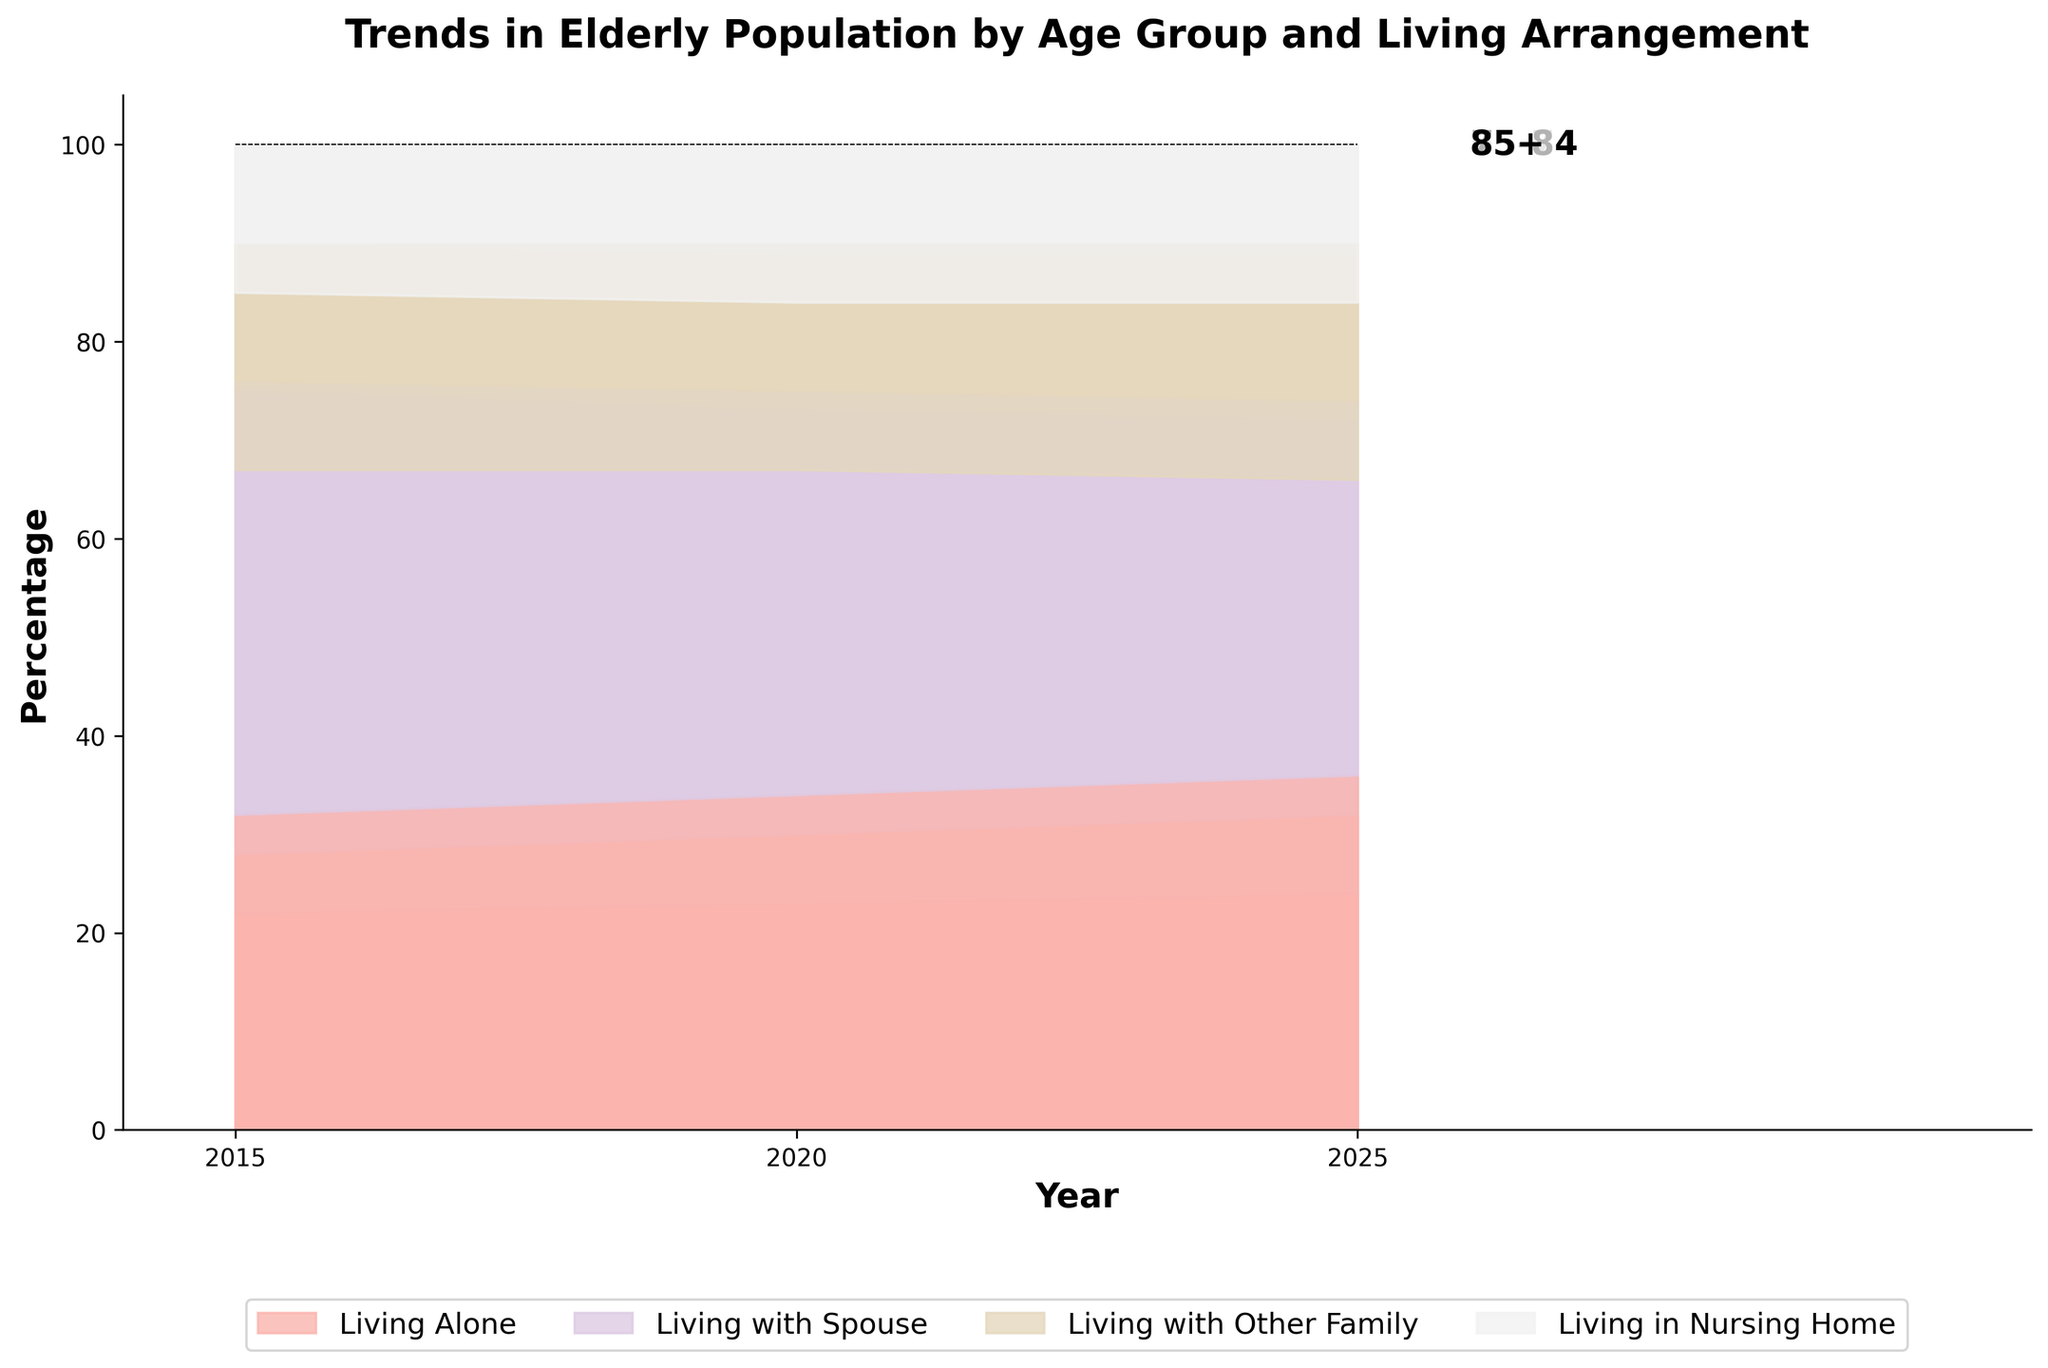What's the title of the figure? The title is usually located at the top of the figure and describes what the chart is about. Checking the top-middle area of the rendered chart will reveal the title.
Answer: Trends in Elderly Population by Age Group and Living Arrangement What are the age groups depicted in the chart? Age groups are usually indicated on the figure through labels, which can be found directly on the plot or in the legend. By observing these labels, we can identify the age groups.
Answer: 65-74, 75-84, 85+ What percentage of the 75-84 age group was living alone in 2020? To find this information, locate the year 2020 on the x-axis, find the 75-84 age group, and look at the area segment corresponding to "Living Alone."
Answer: 30% How did the percentage of the 85+ age group living with a spouse change from 2015 to 2025? Check the 85+ age group sections for 2015 and 2025. Find and compare the values for "Living with Spouse" in these two years. Calculate the difference.
Answer: Decreased from 35% to 30% In 2025, what living arrangement had the smallest percentage for the 65-74 age group? Look at the year 2025 for the 65-74 age group and compare the areas of the different living arrangements to find the smallest one.
Answer: Living in Nursing Home What is the trend in the percentage of elderly living alone from 2015 to 2025 for the age group 75-84? Look at the sections for "Living Alone" for the 75-84 age group across these years. Observe how the percentage changes over time.
Answer: Increasing Which age group has the highest percentage of individuals living with other family members in 2025? Compare the "Living with Other Family" segments for all age groups in 2025. Identify the age group with the largest segment.
Answer: 85+ Compare the percentage of the elderly living in nursing homes for the 85+ age group in 2015 and 2025. What do you observe? Look at the "Living in Nursing Home" areas for the 85+ age group in both years. Compare the sizes of these areas to see how the percentage has changed.
Answer: Slight increase from 15% to 16% What is the sum of percentages for living alone and living with a spouse for the 65-74 age group in 2020? Identify the percentage for "Living Alone" (23%) and "Living with Spouse" (50%) for the 65-74 age group in 2020. Add these two values together.
Answer: 73% Which living arrangement shows a consistent percentage for the 75-84 age group from 2015 to 2025? Look at the percentages for each living arrangement category for the 75-84 age group over the years. Identify which category maintains a steady percentage.
Answer: Living in Nursing Home (10%) 